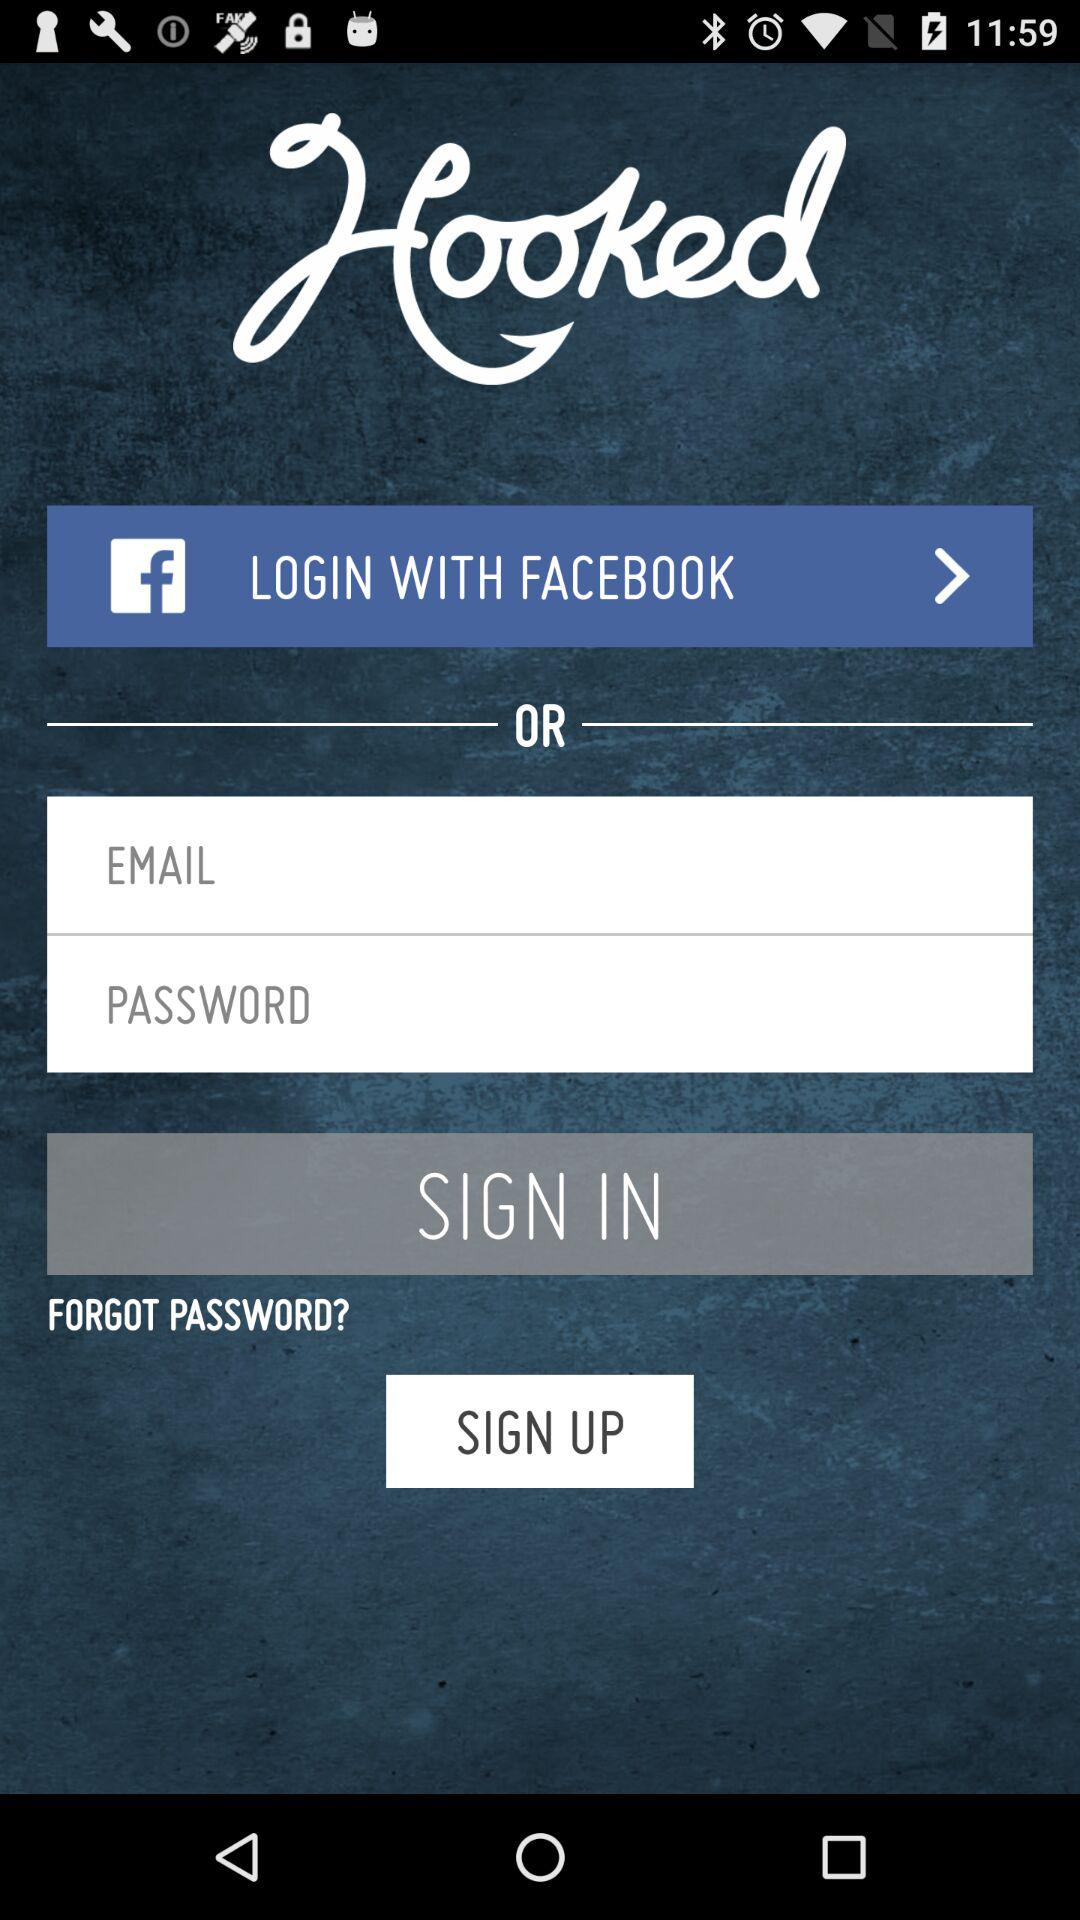What is the name of the application? The name of the application is "Hooked". 